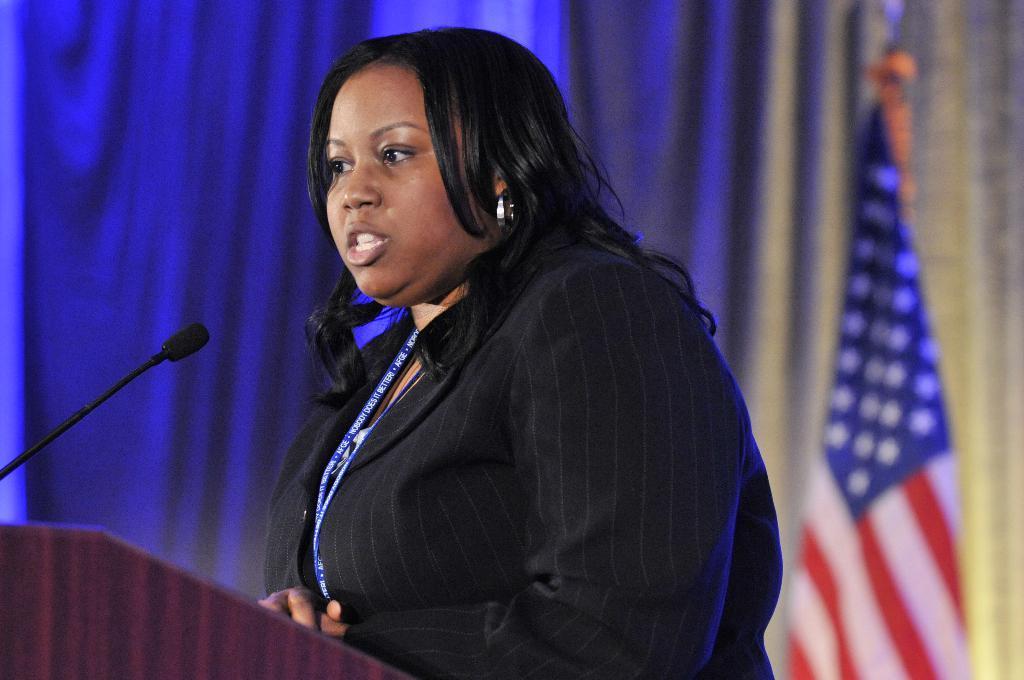In one or two sentences, can you explain what this image depicts? In this picture we can see a woman standing in front of the podium. We can see a microphone on the left side. There is a flag visible on the right side. We can see a blue curtain in the background. 